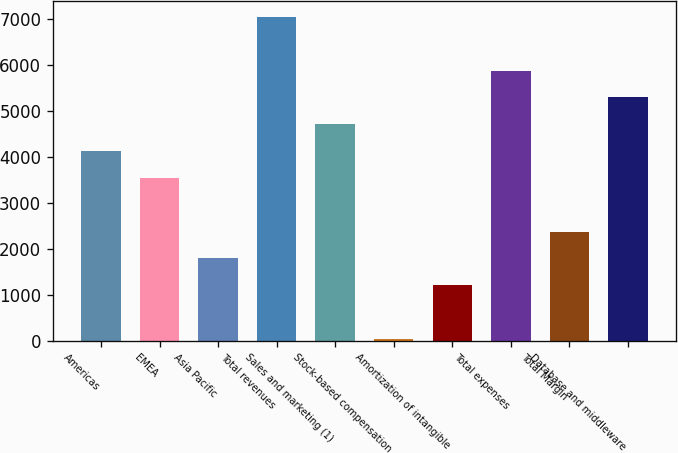Convert chart. <chart><loc_0><loc_0><loc_500><loc_500><bar_chart><fcel>Americas<fcel>EMEA<fcel>Asia Pacific<fcel>Total revenues<fcel>Sales and marketing (1)<fcel>Stock-based compensation<fcel>Amortization of intangible<fcel>Total expenses<fcel>Total Margin<fcel>Database and middleware<nl><fcel>4128.8<fcel>3544.4<fcel>1791.2<fcel>7050.8<fcel>4713.2<fcel>38<fcel>1206.8<fcel>5882<fcel>2375.6<fcel>5297.6<nl></chart> 